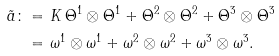Convert formula to latex. <formula><loc_0><loc_0><loc_500><loc_500>\tilde { a } \colon = & \ K \, \Theta ^ { 1 } \otimes \Theta ^ { 1 } + \Theta ^ { 2 } \otimes \Theta ^ { 2 } + \Theta ^ { 3 } \otimes \Theta ^ { 3 } \\ = & \ \omega ^ { 1 } \otimes \omega ^ { 1 } + \omega ^ { 2 } \otimes \omega ^ { 2 } + \omega ^ { 3 } \otimes \omega ^ { 3 } .</formula> 